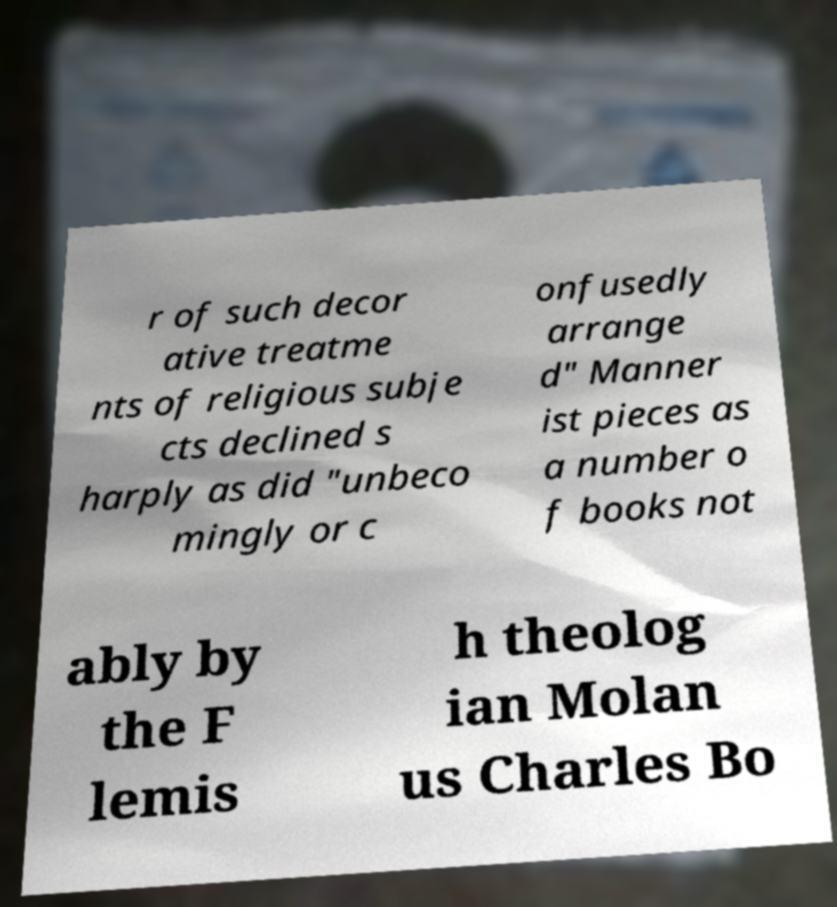There's text embedded in this image that I need extracted. Can you transcribe it verbatim? r of such decor ative treatme nts of religious subje cts declined s harply as did "unbeco mingly or c onfusedly arrange d" Manner ist pieces as a number o f books not ably by the F lemis h theolog ian Molan us Charles Bo 